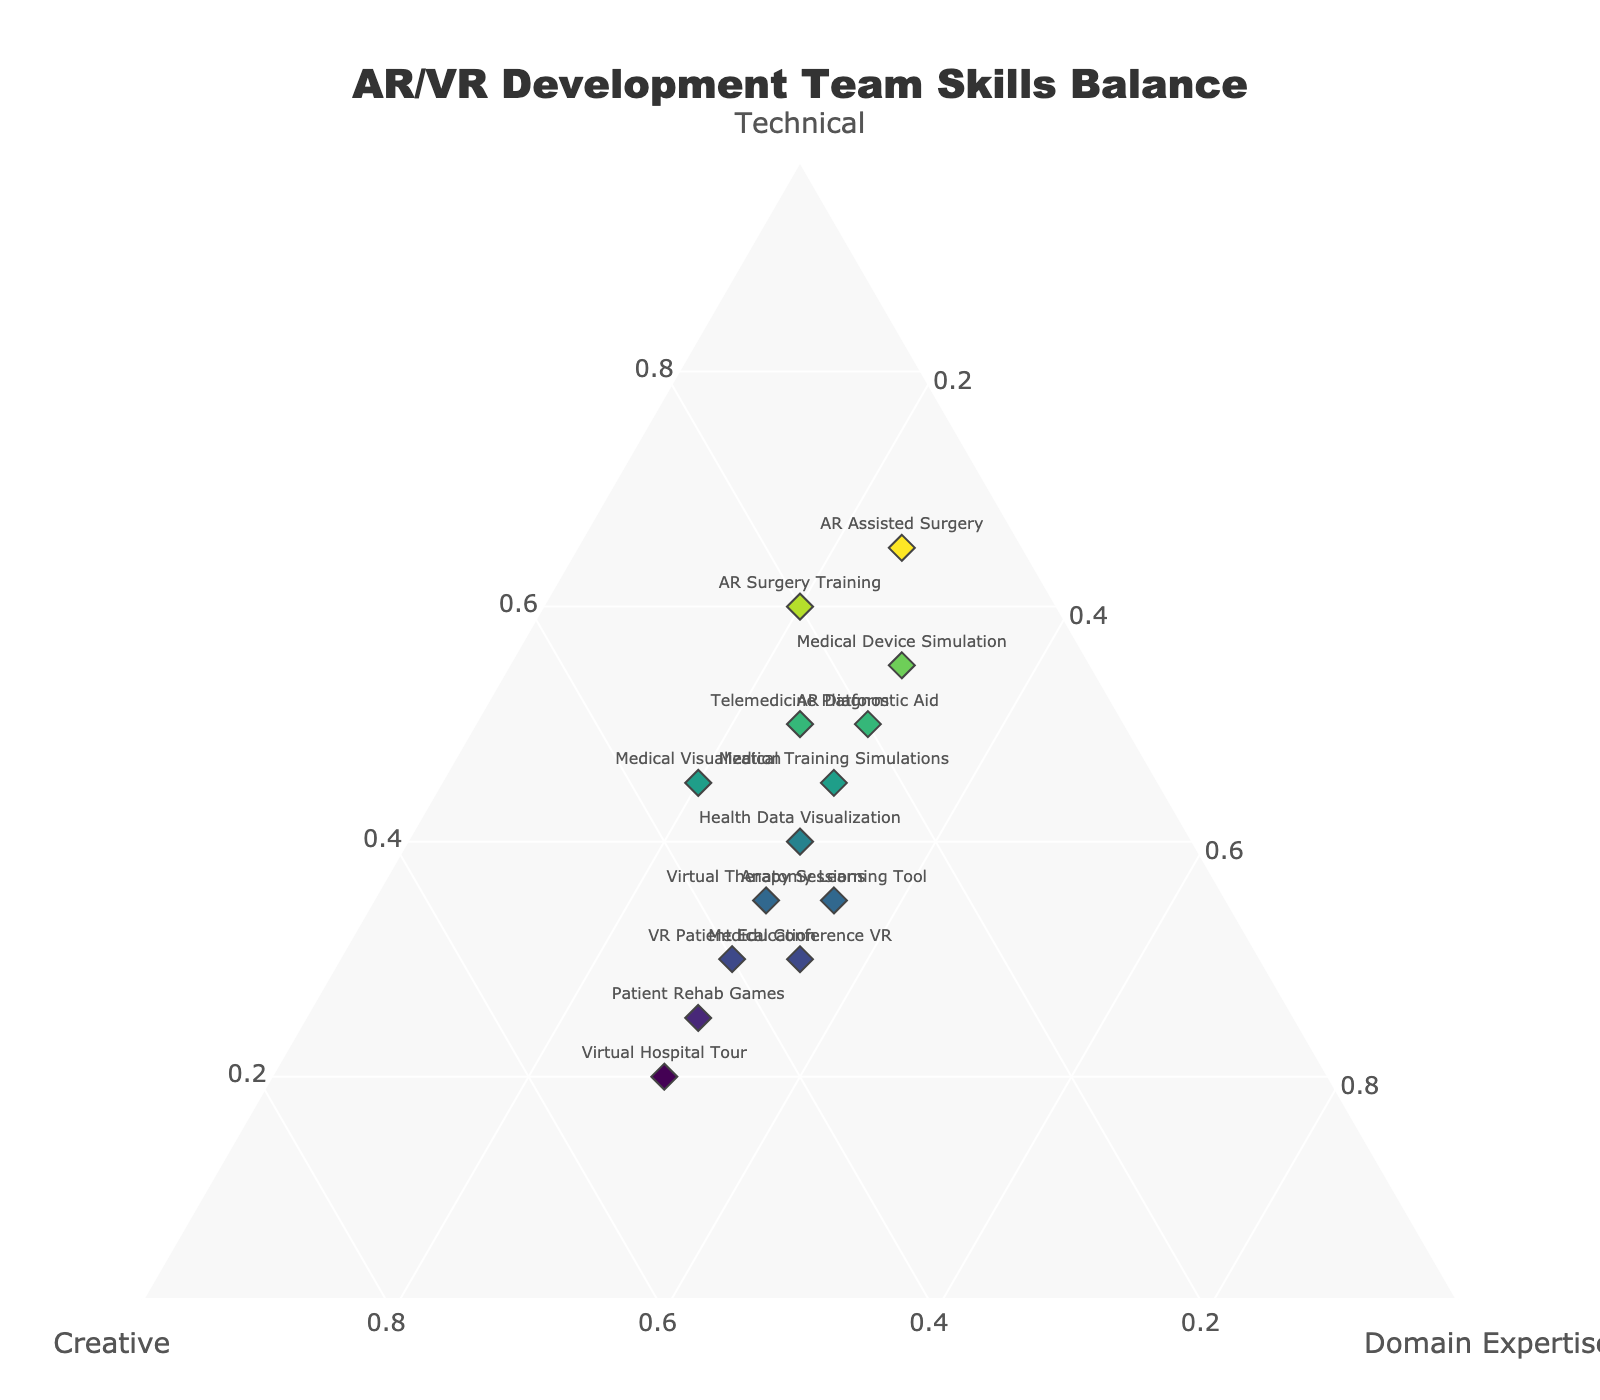What's the title of the ternary plot? The title is usually text displayed prominently at the top of the plot. By examining the image, you can see the title text.
Answer: AR/VR Development Team Skills Balance How many teams are represented in the ternary plot? Count all the unique data points labeled with team names on the plot. Each point should have a team name associated with it.
Answer: 14 Which team has the highest percentage of Technical skills? Look for the data point positioned closest to the Technical vertex. The position indicates the concentration level of Technical skills.
Answer: AR Assisted Surgery Which team has the most balanced skills representation (i.e., closest to equilateral distribution among Technical, Creative, and Domain Expertise)? Identify the data point that is closest to the center of the plot, where all three skill components would be closest to 33.3%.
Answer: Anatomy Learning Tool What is the percentage of Creative skills for Virtual Hospital Tour? Find the data point labeled "Virtual Hospital Tour" and read the percentage value associated with the Creative component.
Answer: 50% Compare the Technical skills between "AR Surgery Training" and "Telemedicine Platform" teams. Which one has higher technical skills? Locate both data points and look at their distance from the Technical vertex. Closer distance to the vertex indicates a higher percentage of Technical skills.
Answer: AR Surgery Training What's the average percentage of Domain Expertise across all teams? Sum up all the Domain Expertise percentages from the dataset, then divide by the number of teams (14) to find the average.
Answer: (20+30+20+25+35+30+30+30+25+30+35+30+30+30) / 14 = 28.2% Identify the team with the lowest Creative skills and state its percentage. Look for the data point furthest from the Creative vertex and note its Creative percentage.
Answer: AR Assisted Surgery, 10% Which team has equal percentages of Creative and Domain Expertise skills? Find the data point where the Creative percentage is the same as Domain Expertise percentage by examining the labels.
Answer: Medical Conference VR 